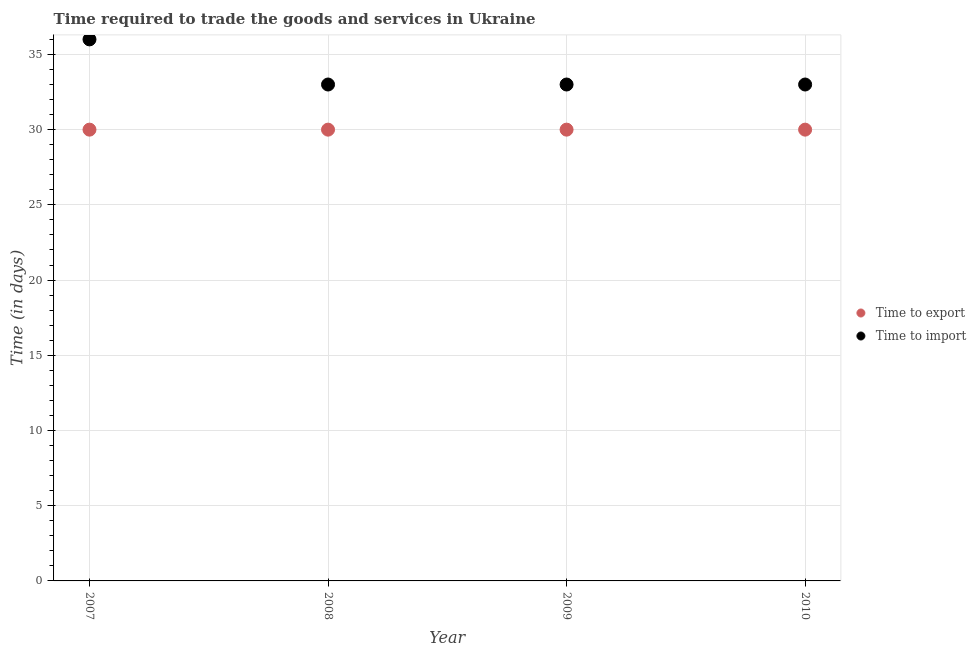How many different coloured dotlines are there?
Provide a succinct answer. 2. Is the number of dotlines equal to the number of legend labels?
Ensure brevity in your answer.  Yes. What is the time to import in 2008?
Provide a succinct answer. 33. Across all years, what is the maximum time to export?
Offer a very short reply. 30. Across all years, what is the minimum time to export?
Provide a short and direct response. 30. In which year was the time to export minimum?
Provide a succinct answer. 2007. What is the total time to import in the graph?
Your answer should be very brief. 135. What is the difference between the time to import in 2007 and that in 2010?
Offer a terse response. 3. What is the difference between the time to import in 2010 and the time to export in 2009?
Give a very brief answer. 3. What is the average time to import per year?
Provide a succinct answer. 33.75. In the year 2008, what is the difference between the time to export and time to import?
Make the answer very short. -3. In how many years, is the time to export greater than 20 days?
Make the answer very short. 4. Is the time to export in 2007 less than that in 2010?
Offer a very short reply. No. Is the difference between the time to import in 2008 and 2009 greater than the difference between the time to export in 2008 and 2009?
Give a very brief answer. No. What is the difference between the highest and the second highest time to export?
Your answer should be very brief. 0. What is the difference between the highest and the lowest time to import?
Your answer should be very brief. 3. In how many years, is the time to import greater than the average time to import taken over all years?
Your answer should be very brief. 1. How many dotlines are there?
Give a very brief answer. 2. Does the graph contain grids?
Keep it short and to the point. Yes. Where does the legend appear in the graph?
Your answer should be very brief. Center right. How many legend labels are there?
Offer a very short reply. 2. What is the title of the graph?
Ensure brevity in your answer.  Time required to trade the goods and services in Ukraine. What is the label or title of the X-axis?
Offer a very short reply. Year. What is the label or title of the Y-axis?
Make the answer very short. Time (in days). What is the Time (in days) in Time to export in 2008?
Make the answer very short. 30. What is the Time (in days) of Time to export in 2009?
Offer a terse response. 30. Across all years, what is the maximum Time (in days) of Time to import?
Give a very brief answer. 36. Across all years, what is the minimum Time (in days) in Time to export?
Offer a very short reply. 30. What is the total Time (in days) in Time to export in the graph?
Give a very brief answer. 120. What is the total Time (in days) in Time to import in the graph?
Your answer should be compact. 135. What is the difference between the Time (in days) of Time to export in 2007 and that in 2008?
Your answer should be very brief. 0. What is the difference between the Time (in days) of Time to import in 2007 and that in 2008?
Ensure brevity in your answer.  3. What is the difference between the Time (in days) of Time to import in 2007 and that in 2009?
Make the answer very short. 3. What is the difference between the Time (in days) in Time to export in 2008 and that in 2010?
Provide a short and direct response. 0. What is the difference between the Time (in days) in Time to import in 2008 and that in 2010?
Make the answer very short. 0. What is the difference between the Time (in days) in Time to export in 2007 and the Time (in days) in Time to import in 2009?
Your answer should be very brief. -3. What is the difference between the Time (in days) in Time to export in 2007 and the Time (in days) in Time to import in 2010?
Provide a short and direct response. -3. What is the difference between the Time (in days) of Time to export in 2009 and the Time (in days) of Time to import in 2010?
Offer a very short reply. -3. What is the average Time (in days) in Time to export per year?
Ensure brevity in your answer.  30. What is the average Time (in days) of Time to import per year?
Offer a terse response. 33.75. In the year 2007, what is the difference between the Time (in days) of Time to export and Time (in days) of Time to import?
Offer a terse response. -6. What is the ratio of the Time (in days) in Time to import in 2007 to that in 2009?
Provide a short and direct response. 1.09. What is the ratio of the Time (in days) of Time to export in 2007 to that in 2010?
Offer a terse response. 1. What is the ratio of the Time (in days) in Time to import in 2007 to that in 2010?
Give a very brief answer. 1.09. What is the ratio of the Time (in days) of Time to export in 2008 to that in 2009?
Offer a very short reply. 1. What is the ratio of the Time (in days) in Time to import in 2008 to that in 2009?
Offer a very short reply. 1. What is the ratio of the Time (in days) in Time to import in 2008 to that in 2010?
Make the answer very short. 1. What is the ratio of the Time (in days) in Time to export in 2009 to that in 2010?
Offer a very short reply. 1. What is the difference between the highest and the lowest Time (in days) in Time to import?
Your response must be concise. 3. 